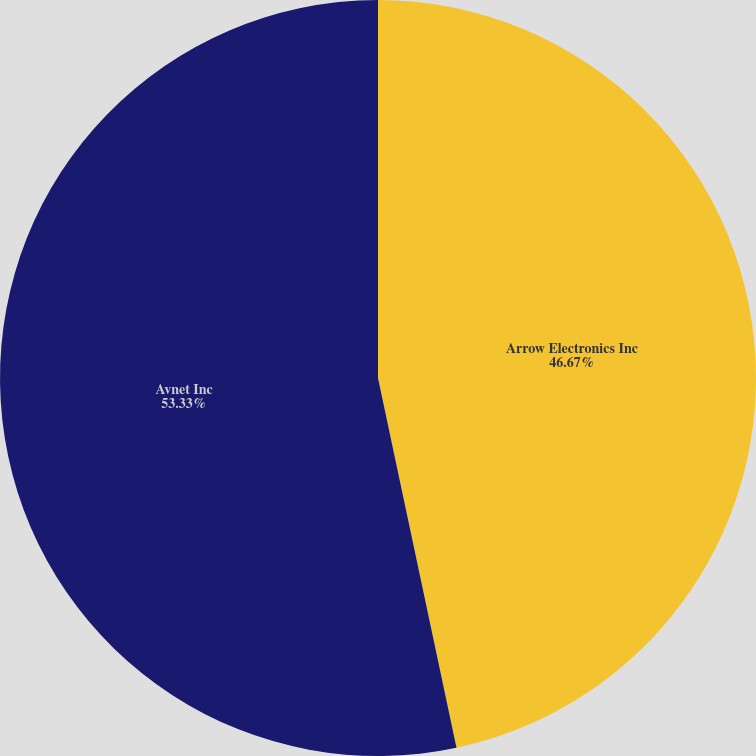Convert chart to OTSL. <chart><loc_0><loc_0><loc_500><loc_500><pie_chart><fcel>Arrow Electronics Inc<fcel>Avnet Inc<nl><fcel>46.67%<fcel>53.33%<nl></chart> 